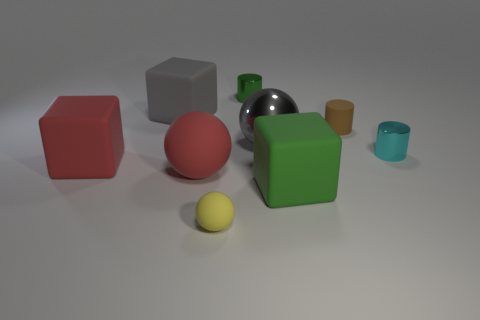Add 1 tiny green shiny cylinders. How many objects exist? 10 Subtract all cubes. How many objects are left? 6 Add 4 small green objects. How many small green objects are left? 5 Add 8 small yellow objects. How many small yellow objects exist? 9 Subtract 0 blue cubes. How many objects are left? 9 Subtract all small yellow things. Subtract all gray balls. How many objects are left? 7 